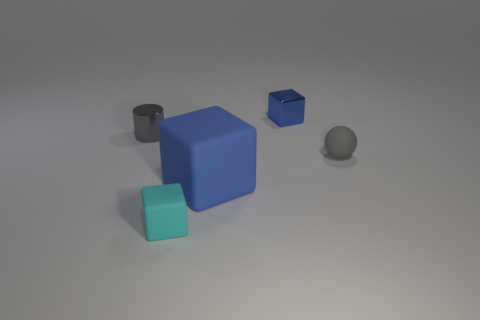Subtract all cyan cylinders. How many blue blocks are left? 2 Subtract 1 blocks. How many blocks are left? 2 Add 2 tiny blue objects. How many objects exist? 7 Subtract all matte balls. Subtract all blue rubber cubes. How many objects are left? 3 Add 4 large rubber blocks. How many large rubber blocks are left? 5 Add 2 small matte cubes. How many small matte cubes exist? 3 Subtract 0 red cylinders. How many objects are left? 5 Subtract all blocks. How many objects are left? 2 